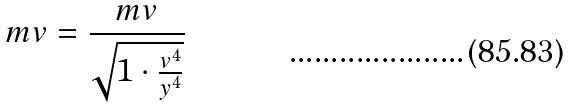Convert formula to latex. <formula><loc_0><loc_0><loc_500><loc_500>m v = \frac { m v } { \sqrt { 1 \cdot \frac { v ^ { 4 } } { y ^ { 4 } } } }</formula> 